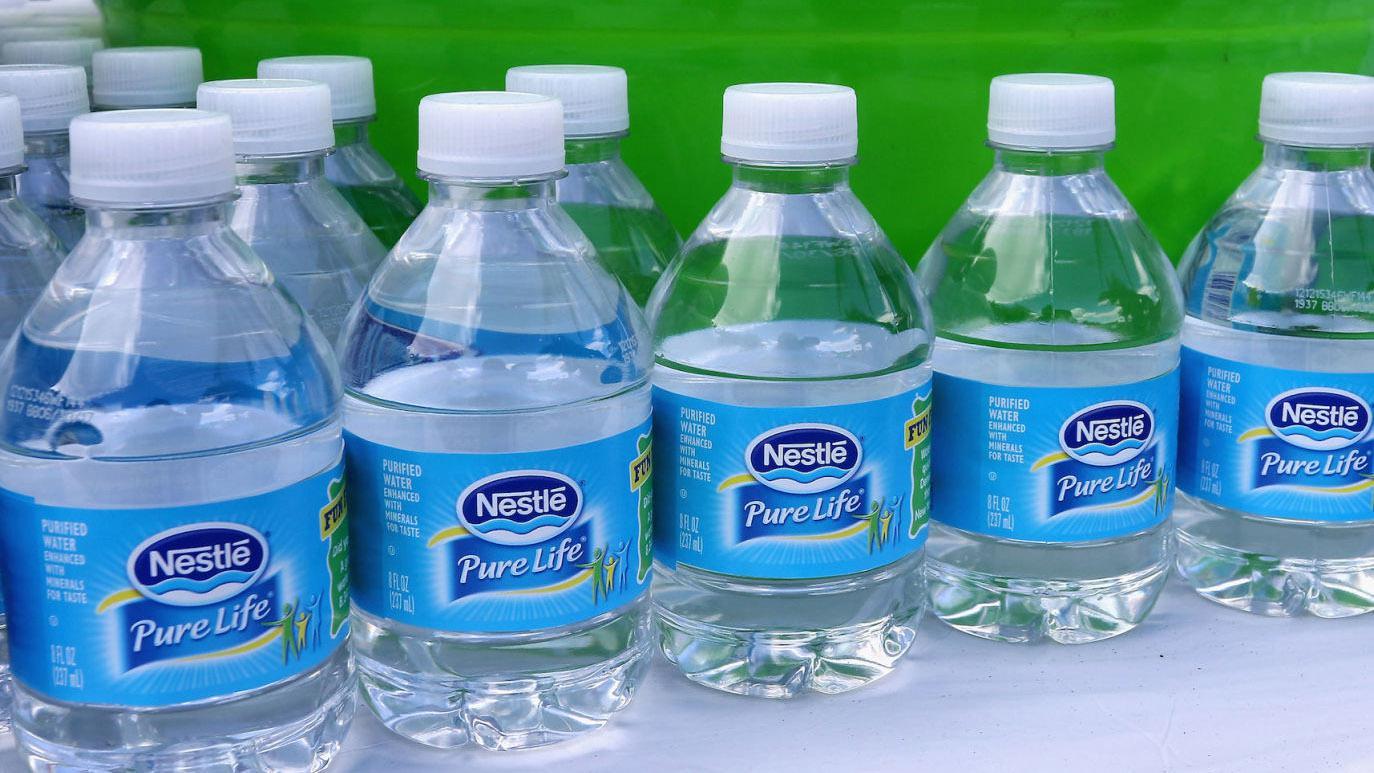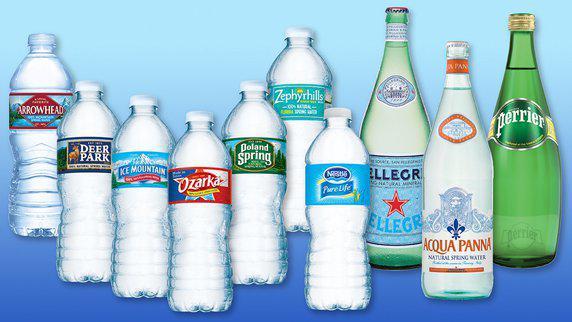The first image is the image on the left, the second image is the image on the right. Given the left and right images, does the statement "There is exactly one water bottle in the image on the left." hold true? Answer yes or no. No. The first image is the image on the left, the second image is the image on the right. Assess this claim about the two images: "An image shows exactly one water bottle.". Correct or not? Answer yes or no. No. 